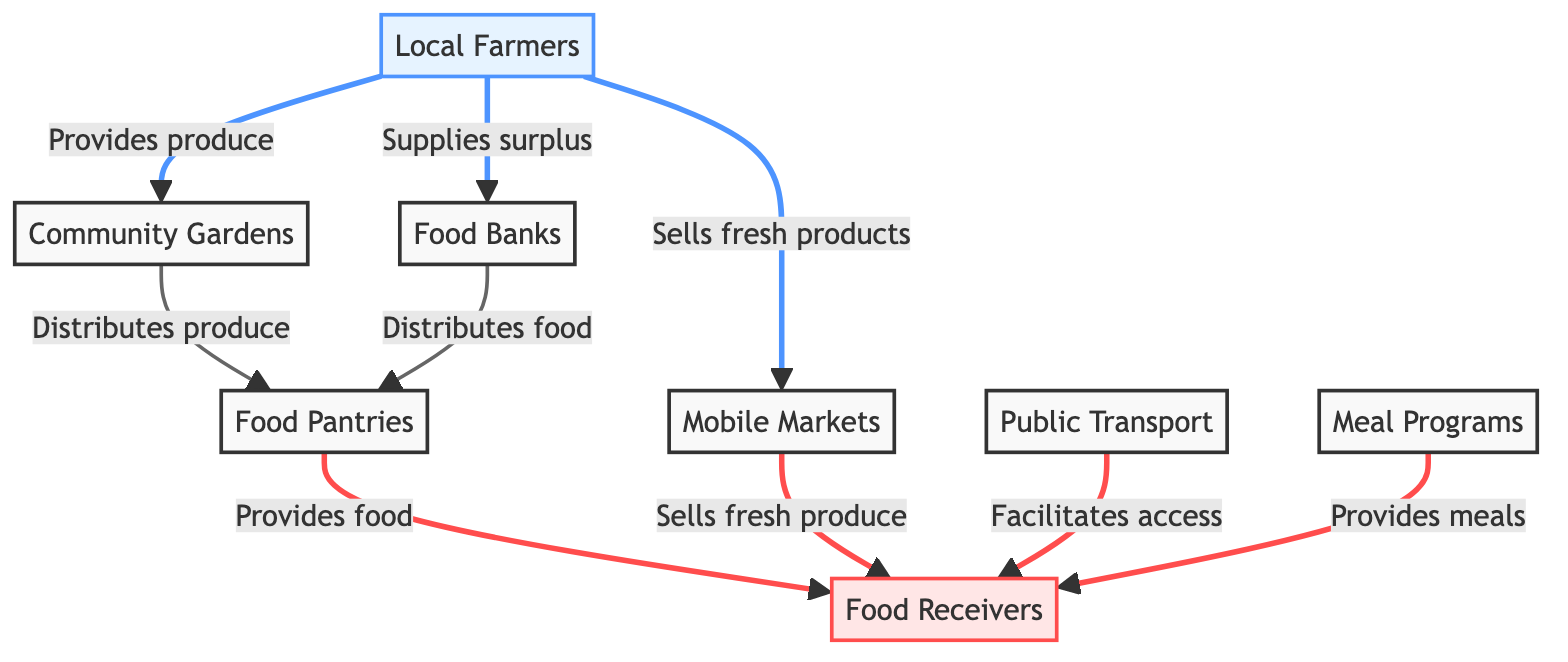What are the sources providing food in this diagram? The sources are Local Farmers and Community Gardens, as indicated by the flows originating from these two nodes towards other nodes in the diagram.
Answer: Local Farmers, Community Gardens How many receivers are there in this diagram? The receivers are represented by the Food Receivers node. The diagram shows only one receiver node, which indicates that it is the end point for food distribution.
Answer: 1 Which service distributes food to Food Pantries? Both Food Banks and Community Gardens distribute food to Food Pantries, as depicted by the arrows pointing towards the Food Pantries node from these two service nodes.
Answer: Food Banks, Community Gardens What role does Public Transport play in this diagram? Public Transport facilitates access to Food Receivers, meaning it provides the necessary transportation options for people to reach available food services.
Answer: Facilitates access Which service provides meals to Food Receivers? Meal Programs provide meals to Food Receivers, as shown by the direct flow from the Meal Programs node to the Food Receivers node.
Answer: Meal Programs How do Local Farmers support Mobile Markets? Local Farmers sell fresh products to Mobile Markets, which is indicated by the flow from Local Farmers to the Mobile Markets node in the diagram.
Answer: Sells fresh products What is the relationship between Food Banks and Food Receivers? Food Banks distribute food to Food Receivers, as illustrated by the flow connecting the Food Banks node directly to the Food Receivers node.
Answer: Distributes food Which entities connect to Food Pantries in the supply chain? Food Pantries are connected to Community Gardens and Food Banks, which both distribute food to them as indicated by the arrows pointing to the Food Pantries node from these entities.
Answer: Community Gardens, Food Banks What distinguishes Fresh Markets from Food Banks in this diagram? Fresh Markets sell fresh produce to Food Receivers, while Food Banks distribute food to Food Pantries, highlighting differing roles in the supply chain regarding fresh food delivery and overall distribution methodology.
Answer: Fresh produce, Distributes food 